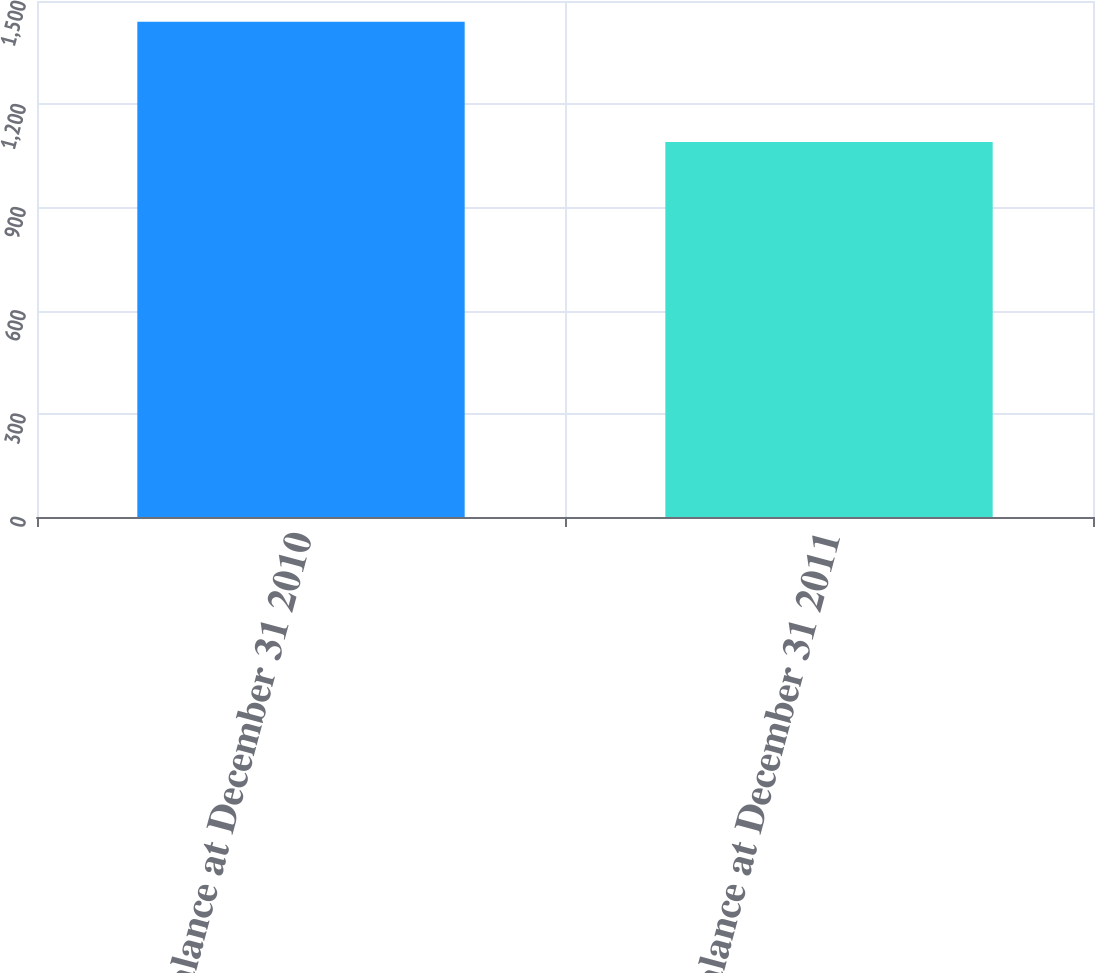<chart> <loc_0><loc_0><loc_500><loc_500><bar_chart><fcel>Balance at December 31 2010<fcel>Balance at December 31 2011<nl><fcel>1440<fcel>1090<nl></chart> 